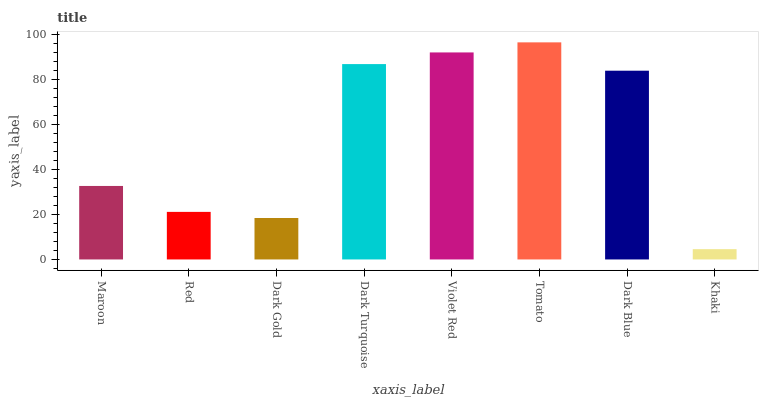Is Khaki the minimum?
Answer yes or no. Yes. Is Tomato the maximum?
Answer yes or no. Yes. Is Red the minimum?
Answer yes or no. No. Is Red the maximum?
Answer yes or no. No. Is Maroon greater than Red?
Answer yes or no. Yes. Is Red less than Maroon?
Answer yes or no. Yes. Is Red greater than Maroon?
Answer yes or no. No. Is Maroon less than Red?
Answer yes or no. No. Is Dark Blue the high median?
Answer yes or no. Yes. Is Maroon the low median?
Answer yes or no. Yes. Is Dark Gold the high median?
Answer yes or no. No. Is Tomato the low median?
Answer yes or no. No. 